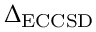Convert formula to latex. <formula><loc_0><loc_0><loc_500><loc_500>\Delta _ { E C C S D }</formula> 